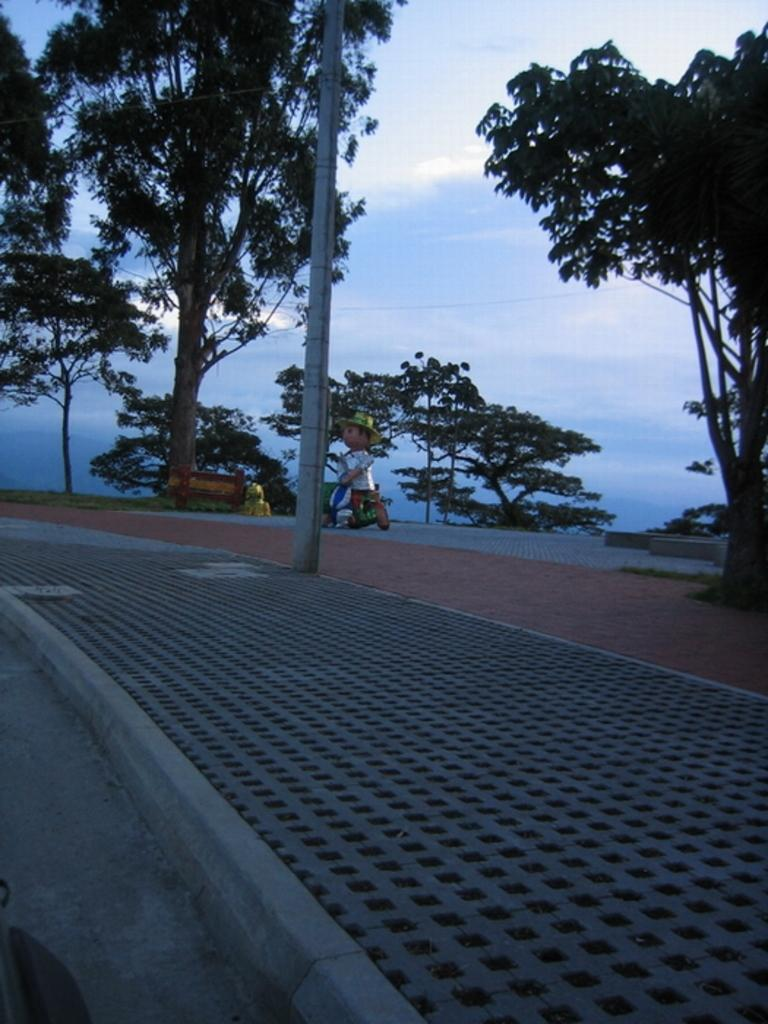What type of path is visible in the image? There is a footpath in the image. What kind of vegetation can be seen in the image? There are green trees in the image. What part of the natural environment is visible in the image? The sky is visible in the image. How many eggs are hidden in the trees in the image? There are no eggs present in the image; it features a footpath and green trees. 